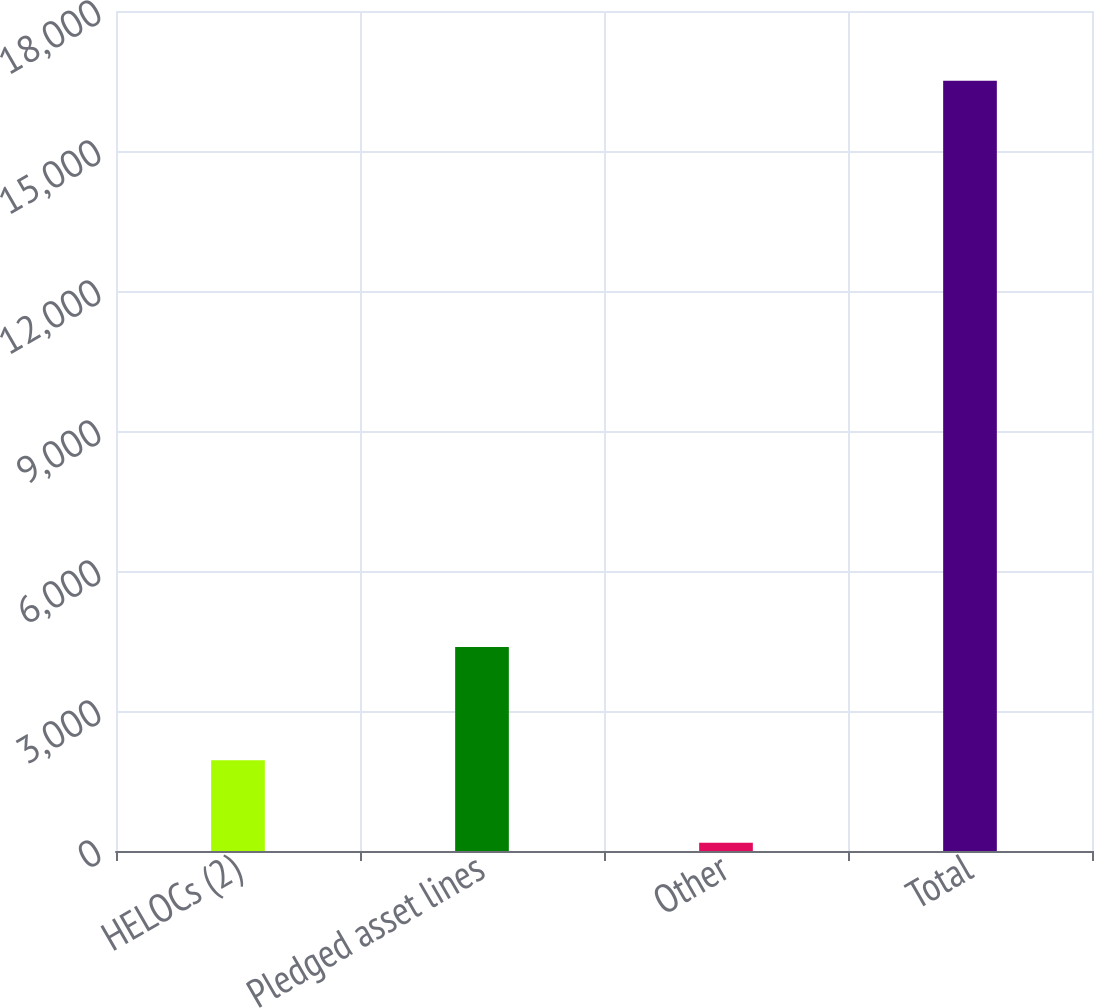<chart> <loc_0><loc_0><loc_500><loc_500><bar_chart><fcel>HELOCs (2)<fcel>Pledged asset lines<fcel>Other<fcel>Total<nl><fcel>1943<fcel>4369<fcel>176<fcel>16504<nl></chart> 